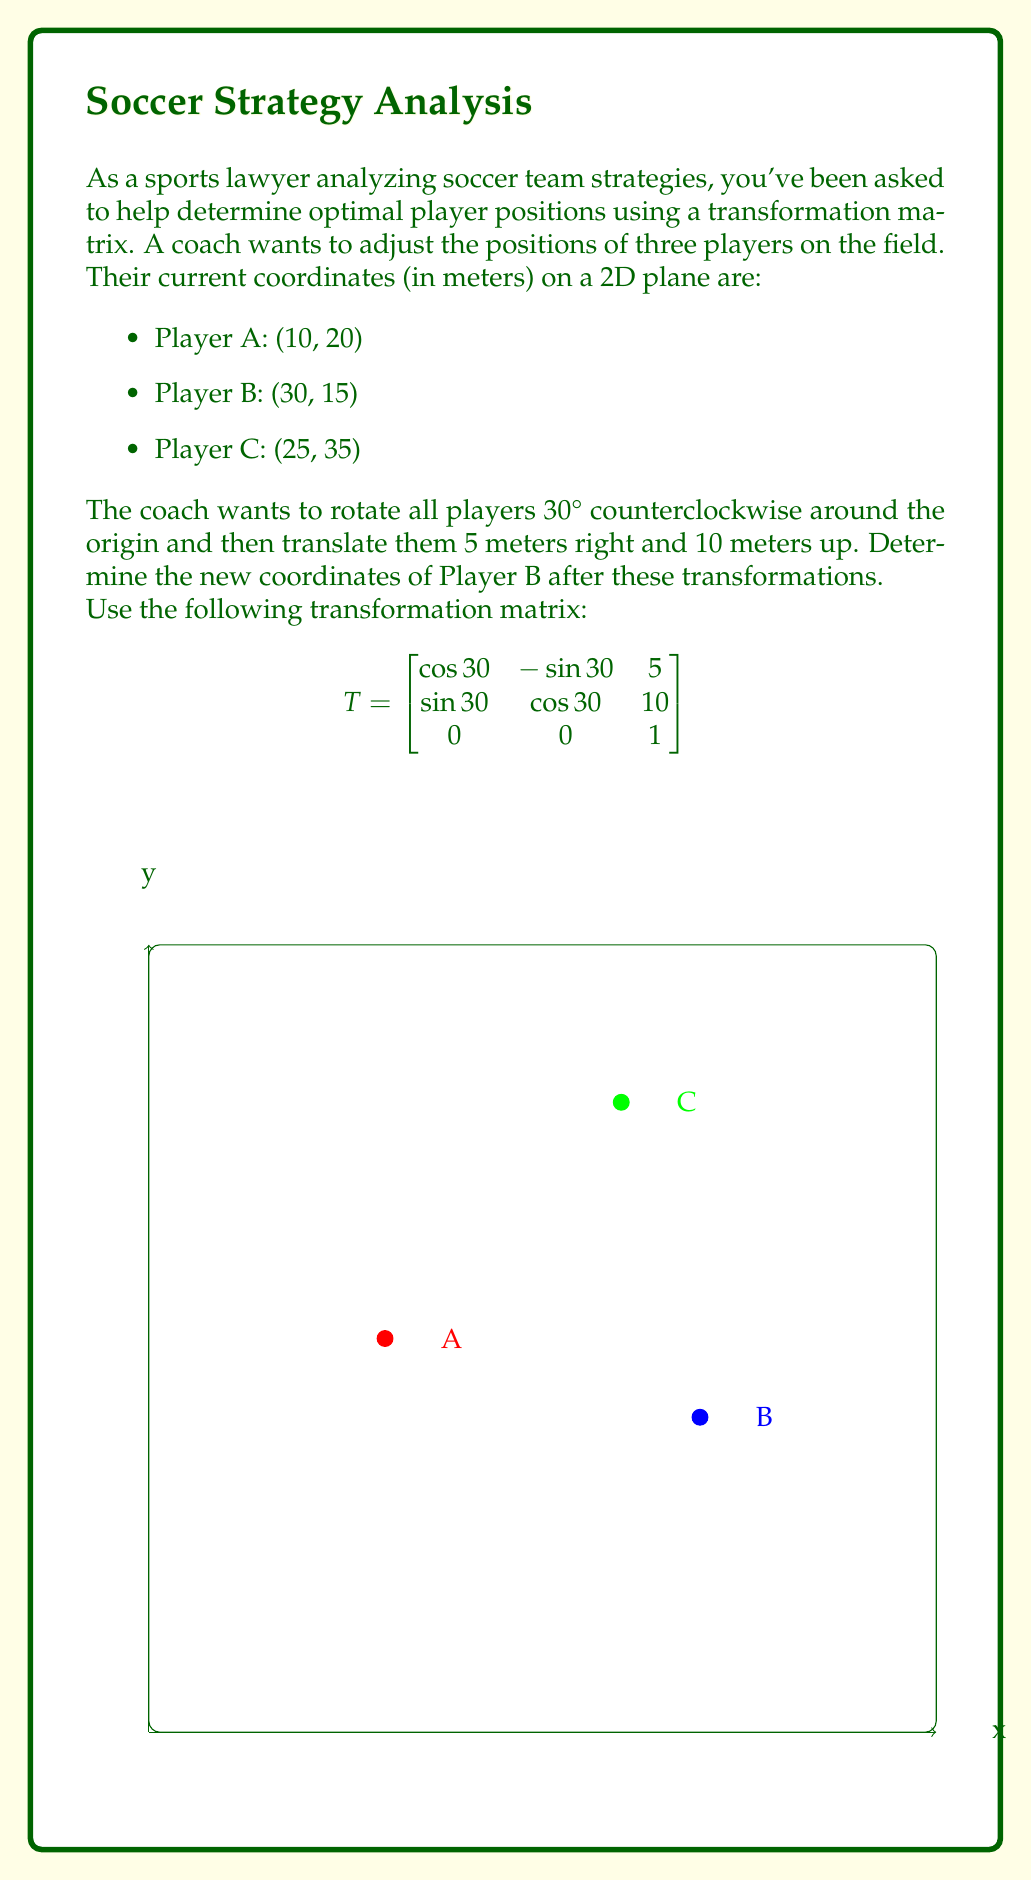Show me your answer to this math problem. Let's approach this step-by-step:

1) First, we need to represent Player B's position as a 3x1 matrix in homogeneous coordinates:

   $$B = \begin{bmatrix} 30 \\ 15 \\ 1 \end{bmatrix}$$

2) The transformation matrix T is given as:

   $$T = \begin{bmatrix}
   \cos 30° & -\sin 30° & 5 \\
   \sin 30° & \cos 30° & 10 \\
   0 & 0 & 1
   \end{bmatrix}$$

3) We need to multiply T by B to get the new position B':

   $$B' = TB$$

4) Let's perform this multiplication:

   $$\begin{bmatrix}
   \cos 30° & -\sin 30° & 5 \\
   \sin 30° & \cos 30° & 10 \\
   0 & 0 & 1
   \end{bmatrix} \begin{bmatrix} 30 \\ 15 \\ 1 \end{bmatrix}$$

5) Calculating:

   $$\begin{bmatrix}
   30\cos 30° - 15\sin 30° + 5 \\
   30\sin 30° + 15\cos 30° + 10 \\
   1
   \end{bmatrix}$$

6) Using the values $\cos 30° \approx 0.866$ and $\sin 30° \approx 0.5$:

   $$\begin{bmatrix}
   30(0.866) - 15(0.5) + 5 \\
   30(0.5) + 15(0.866) + 10 \\
   1
   \end{bmatrix}$$

7) Calculating the final result:

   $$\begin{bmatrix}
   31.48 \\
   33.49 \\
   1
   \end{bmatrix}$$

Therefore, Player B's new position is approximately (31.48, 33.49).
Answer: (31.48, 33.49) 